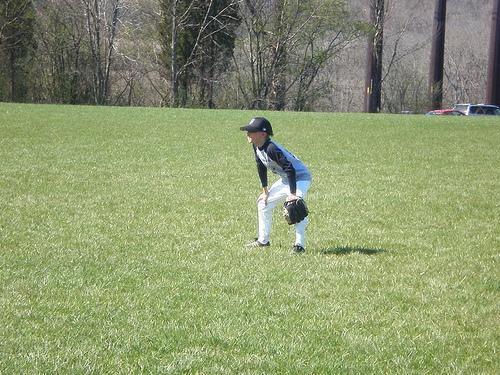How many players are visible?
Give a very brief answer. 1. 